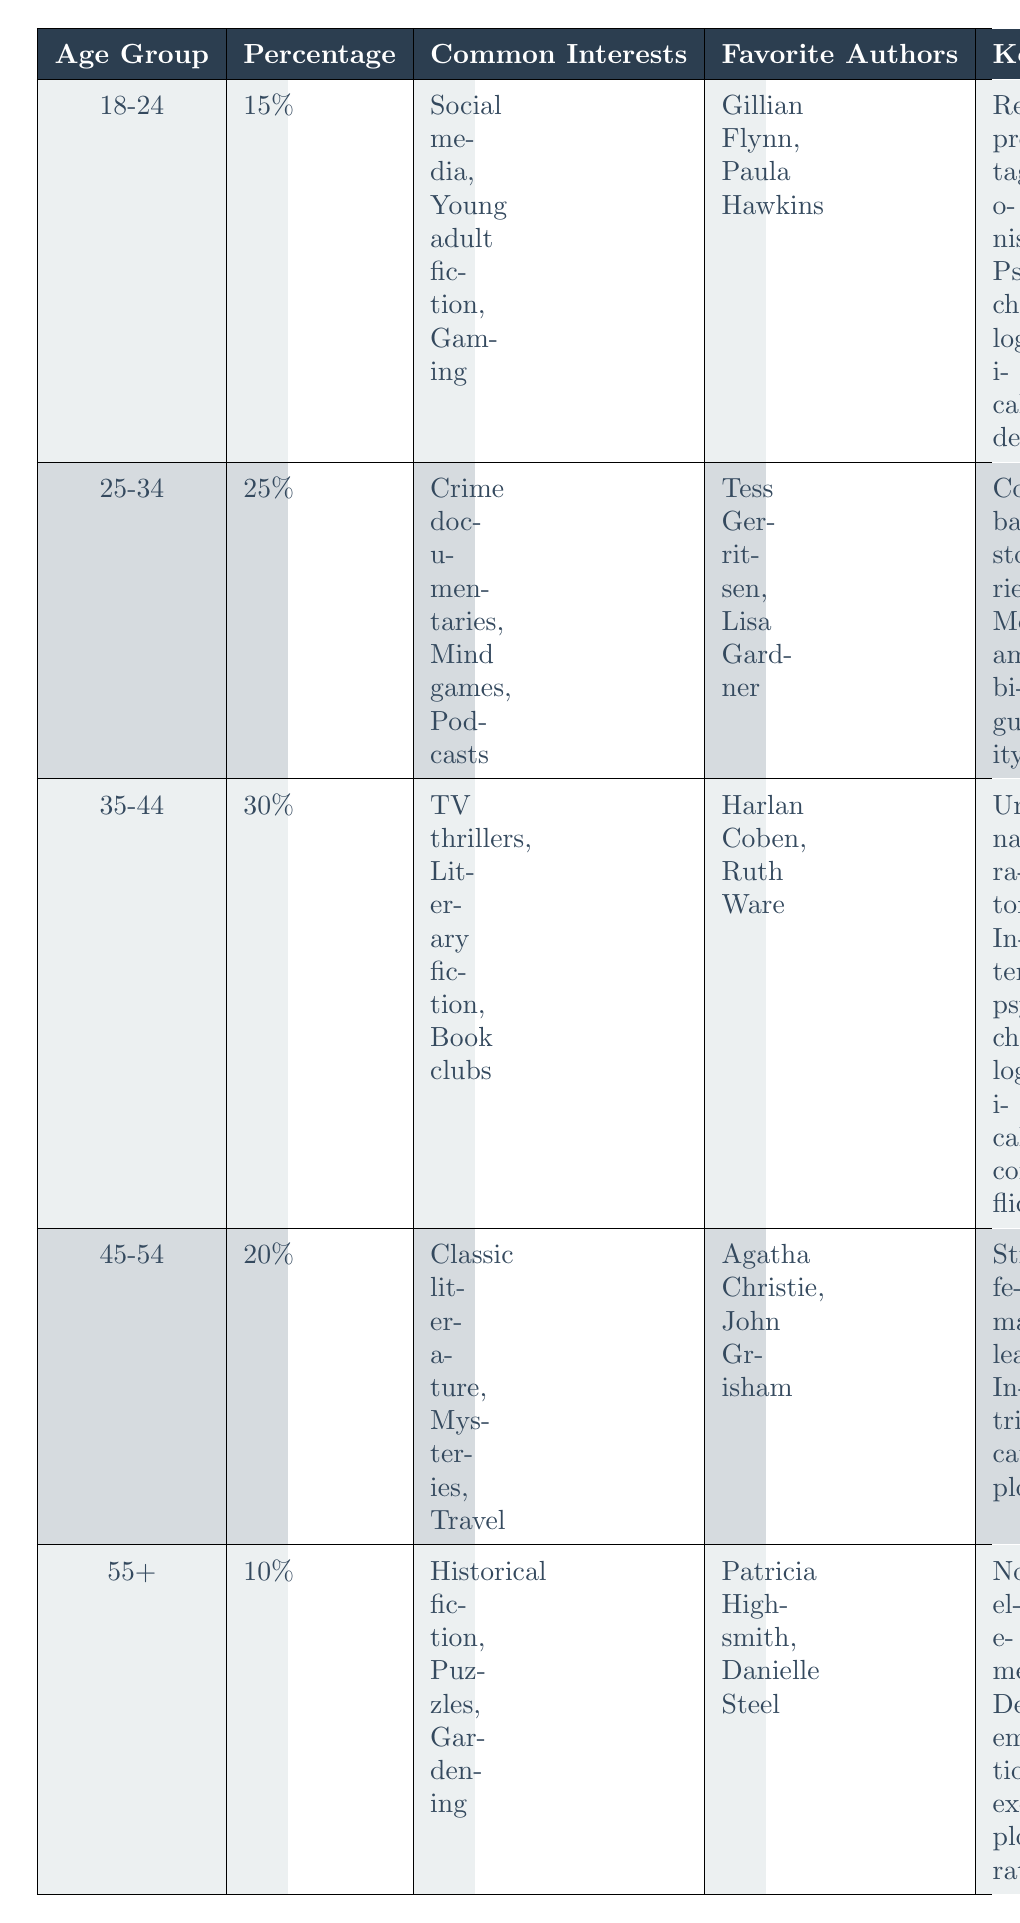What percentage of readers are aged 35-44? The table lists the age group 35-44 with a corresponding percentage of 30% under that column.
Answer: 30% Which age group has the highest interest in TV thrillers? By examining the common interests for each age group, it is noted that the 35-44 age group lists TV thrillers as one of their common interests.
Answer: 35-44 What are the favorite authors of the 45-54 age group? The table specifies that the favorite authors for the age group 45-54 are Agatha Christie and John Grisham as listed under the respective column.
Answer: Agatha Christie, John Grisham Are readers aged 55+ more interested in historical fiction or gaming? The interests for the 55+ group highlight historical fiction while the gaming interest is prominent among the 18-24 age group. Thus, the 55+ group is indeed more interested in historical fiction.
Answer: Yes What is the total percentage of readers aged 25-34 and 35-44? To find this, add the percentages for both age groups: 25% (25-34) + 30% (35-44) = 55%.
Answer: 55% Do readers aged 18-24 prefer relatable protagonists or complex backstories? The key character traits preferred by the 18-24 age group include relatable protagonists. On the other hand, complex backstories are favored by the 25-34 group. Therefore, the preference is for relatable protagonists.
Answer: Yes Which key character trait is preferred by the 45-54 age group? The table indicates that the key character traits preferred by the 45-54 age group are strong female leads and intricate plots. Since the question asks for at least one, we can confirm it is one of these traits.
Answer: Strong female leads What age group shows the least interest in psychological thrillers based on percentage? The 55+ age group has the lowest percentage listed at 10%, indicating the least interest compared to other age groups.
Answer: 55+ How many more percentage points do readers aged 35-44 prefer unreliable narrators over relatable protagonists from the 18-24 age group? The 35-44 age group shows a preference for unreliable narrators, while the 18-24 age group prefers relatable protagonists. The difference in percentage points is not directly stated but implied. Both traits are listed distinctly without direct numerical comparison, so this cannot be calculated without prior numerical data allocated specifically to those traits. Therefore, the answer is not directly available.
Answer: Not available 